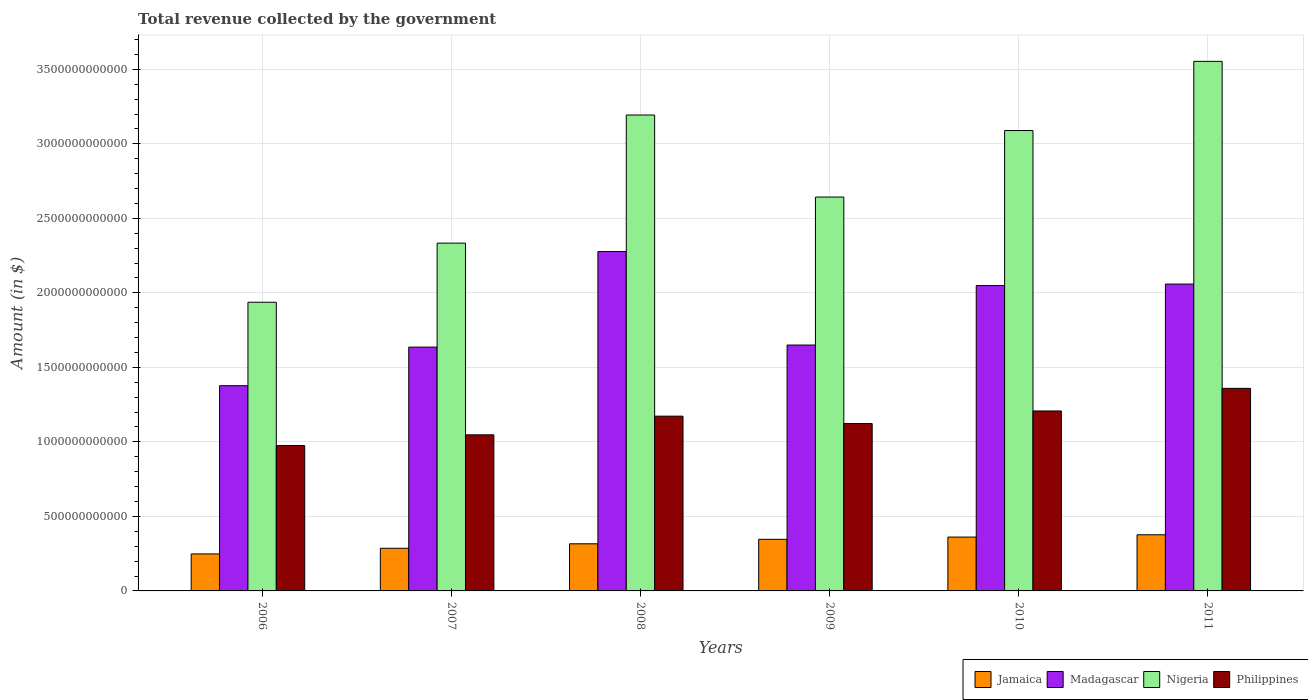How many different coloured bars are there?
Ensure brevity in your answer.  4. How many groups of bars are there?
Your answer should be compact. 6. Are the number of bars per tick equal to the number of legend labels?
Your response must be concise. Yes. Are the number of bars on each tick of the X-axis equal?
Give a very brief answer. Yes. What is the label of the 1st group of bars from the left?
Give a very brief answer. 2006. What is the total revenue collected by the government in Madagascar in 2008?
Provide a succinct answer. 2.28e+12. Across all years, what is the maximum total revenue collected by the government in Nigeria?
Offer a terse response. 3.55e+12. Across all years, what is the minimum total revenue collected by the government in Madagascar?
Ensure brevity in your answer.  1.38e+12. In which year was the total revenue collected by the government in Nigeria maximum?
Ensure brevity in your answer.  2011. What is the total total revenue collected by the government in Madagascar in the graph?
Your response must be concise. 1.10e+13. What is the difference between the total revenue collected by the government in Jamaica in 2006 and that in 2011?
Offer a very short reply. -1.29e+11. What is the difference between the total revenue collected by the government in Madagascar in 2008 and the total revenue collected by the government in Nigeria in 2009?
Your answer should be very brief. -3.66e+11. What is the average total revenue collected by the government in Madagascar per year?
Ensure brevity in your answer.  1.84e+12. In the year 2007, what is the difference between the total revenue collected by the government in Philippines and total revenue collected by the government in Nigeria?
Your answer should be very brief. -1.29e+12. In how many years, is the total revenue collected by the government in Madagascar greater than 300000000000 $?
Ensure brevity in your answer.  6. What is the ratio of the total revenue collected by the government in Madagascar in 2006 to that in 2009?
Keep it short and to the point. 0.83. What is the difference between the highest and the second highest total revenue collected by the government in Nigeria?
Offer a terse response. 3.60e+11. What is the difference between the highest and the lowest total revenue collected by the government in Madagascar?
Offer a very short reply. 9.00e+11. Is the sum of the total revenue collected by the government in Philippines in 2007 and 2008 greater than the maximum total revenue collected by the government in Madagascar across all years?
Give a very brief answer. No. Is it the case that in every year, the sum of the total revenue collected by the government in Nigeria and total revenue collected by the government in Madagascar is greater than the sum of total revenue collected by the government in Philippines and total revenue collected by the government in Jamaica?
Provide a succinct answer. No. What does the 3rd bar from the left in 2009 represents?
Make the answer very short. Nigeria. What does the 3rd bar from the right in 2006 represents?
Keep it short and to the point. Madagascar. Are all the bars in the graph horizontal?
Keep it short and to the point. No. What is the difference between two consecutive major ticks on the Y-axis?
Give a very brief answer. 5.00e+11. What is the title of the graph?
Your answer should be very brief. Total revenue collected by the government. Does "Cyprus" appear as one of the legend labels in the graph?
Offer a terse response. No. What is the label or title of the X-axis?
Offer a very short reply. Years. What is the label or title of the Y-axis?
Your answer should be very brief. Amount (in $). What is the Amount (in $) of Jamaica in 2006?
Your answer should be very brief. 2.48e+11. What is the Amount (in $) in Madagascar in 2006?
Provide a succinct answer. 1.38e+12. What is the Amount (in $) of Nigeria in 2006?
Provide a succinct answer. 1.94e+12. What is the Amount (in $) in Philippines in 2006?
Ensure brevity in your answer.  9.75e+11. What is the Amount (in $) in Jamaica in 2007?
Your response must be concise. 2.86e+11. What is the Amount (in $) of Madagascar in 2007?
Your answer should be very brief. 1.64e+12. What is the Amount (in $) in Nigeria in 2007?
Your response must be concise. 2.33e+12. What is the Amount (in $) in Philippines in 2007?
Ensure brevity in your answer.  1.05e+12. What is the Amount (in $) in Jamaica in 2008?
Ensure brevity in your answer.  3.16e+11. What is the Amount (in $) in Madagascar in 2008?
Provide a succinct answer. 2.28e+12. What is the Amount (in $) in Nigeria in 2008?
Your answer should be compact. 3.19e+12. What is the Amount (in $) of Philippines in 2008?
Ensure brevity in your answer.  1.17e+12. What is the Amount (in $) in Jamaica in 2009?
Your answer should be very brief. 3.46e+11. What is the Amount (in $) of Madagascar in 2009?
Offer a very short reply. 1.65e+12. What is the Amount (in $) in Nigeria in 2009?
Make the answer very short. 2.64e+12. What is the Amount (in $) of Philippines in 2009?
Offer a terse response. 1.12e+12. What is the Amount (in $) in Jamaica in 2010?
Ensure brevity in your answer.  3.61e+11. What is the Amount (in $) of Madagascar in 2010?
Your response must be concise. 2.05e+12. What is the Amount (in $) of Nigeria in 2010?
Your response must be concise. 3.09e+12. What is the Amount (in $) of Philippines in 2010?
Keep it short and to the point. 1.21e+12. What is the Amount (in $) in Jamaica in 2011?
Provide a short and direct response. 3.77e+11. What is the Amount (in $) of Madagascar in 2011?
Your answer should be very brief. 2.06e+12. What is the Amount (in $) of Nigeria in 2011?
Offer a very short reply. 3.55e+12. What is the Amount (in $) in Philippines in 2011?
Provide a succinct answer. 1.36e+12. Across all years, what is the maximum Amount (in $) of Jamaica?
Provide a short and direct response. 3.77e+11. Across all years, what is the maximum Amount (in $) in Madagascar?
Give a very brief answer. 2.28e+12. Across all years, what is the maximum Amount (in $) in Nigeria?
Make the answer very short. 3.55e+12. Across all years, what is the maximum Amount (in $) of Philippines?
Give a very brief answer. 1.36e+12. Across all years, what is the minimum Amount (in $) of Jamaica?
Offer a terse response. 2.48e+11. Across all years, what is the minimum Amount (in $) in Madagascar?
Your response must be concise. 1.38e+12. Across all years, what is the minimum Amount (in $) in Nigeria?
Keep it short and to the point. 1.94e+12. Across all years, what is the minimum Amount (in $) of Philippines?
Give a very brief answer. 9.75e+11. What is the total Amount (in $) in Jamaica in the graph?
Ensure brevity in your answer.  1.93e+12. What is the total Amount (in $) in Madagascar in the graph?
Your answer should be very brief. 1.10e+13. What is the total Amount (in $) in Nigeria in the graph?
Your answer should be compact. 1.67e+13. What is the total Amount (in $) in Philippines in the graph?
Your response must be concise. 6.88e+12. What is the difference between the Amount (in $) of Jamaica in 2006 and that in 2007?
Give a very brief answer. -3.78e+1. What is the difference between the Amount (in $) of Madagascar in 2006 and that in 2007?
Your answer should be very brief. -2.59e+11. What is the difference between the Amount (in $) of Nigeria in 2006 and that in 2007?
Provide a succinct answer. -3.97e+11. What is the difference between the Amount (in $) in Philippines in 2006 and that in 2007?
Offer a very short reply. -7.21e+1. What is the difference between the Amount (in $) of Jamaica in 2006 and that in 2008?
Ensure brevity in your answer.  -6.80e+1. What is the difference between the Amount (in $) in Madagascar in 2006 and that in 2008?
Make the answer very short. -9.00e+11. What is the difference between the Amount (in $) in Nigeria in 2006 and that in 2008?
Offer a very short reply. -1.26e+12. What is the difference between the Amount (in $) in Philippines in 2006 and that in 2008?
Your answer should be compact. -1.97e+11. What is the difference between the Amount (in $) of Jamaica in 2006 and that in 2009?
Keep it short and to the point. -9.79e+1. What is the difference between the Amount (in $) in Madagascar in 2006 and that in 2009?
Your answer should be very brief. -2.73e+11. What is the difference between the Amount (in $) of Nigeria in 2006 and that in 2009?
Provide a short and direct response. -7.06e+11. What is the difference between the Amount (in $) in Philippines in 2006 and that in 2009?
Offer a terse response. -1.48e+11. What is the difference between the Amount (in $) of Jamaica in 2006 and that in 2010?
Ensure brevity in your answer.  -1.13e+11. What is the difference between the Amount (in $) in Madagascar in 2006 and that in 2010?
Keep it short and to the point. -6.72e+11. What is the difference between the Amount (in $) of Nigeria in 2006 and that in 2010?
Ensure brevity in your answer.  -1.15e+12. What is the difference between the Amount (in $) of Philippines in 2006 and that in 2010?
Provide a short and direct response. -2.32e+11. What is the difference between the Amount (in $) of Jamaica in 2006 and that in 2011?
Provide a short and direct response. -1.29e+11. What is the difference between the Amount (in $) of Madagascar in 2006 and that in 2011?
Your response must be concise. -6.82e+11. What is the difference between the Amount (in $) in Nigeria in 2006 and that in 2011?
Your answer should be compact. -1.62e+12. What is the difference between the Amount (in $) in Philippines in 2006 and that in 2011?
Give a very brief answer. -3.84e+11. What is the difference between the Amount (in $) in Jamaica in 2007 and that in 2008?
Ensure brevity in your answer.  -3.02e+1. What is the difference between the Amount (in $) of Madagascar in 2007 and that in 2008?
Offer a very short reply. -6.41e+11. What is the difference between the Amount (in $) of Nigeria in 2007 and that in 2008?
Offer a very short reply. -8.60e+11. What is the difference between the Amount (in $) in Philippines in 2007 and that in 2008?
Your answer should be very brief. -1.25e+11. What is the difference between the Amount (in $) in Jamaica in 2007 and that in 2009?
Offer a terse response. -6.01e+1. What is the difference between the Amount (in $) in Madagascar in 2007 and that in 2009?
Your answer should be compact. -1.38e+1. What is the difference between the Amount (in $) of Nigeria in 2007 and that in 2009?
Provide a succinct answer. -3.09e+11. What is the difference between the Amount (in $) of Philippines in 2007 and that in 2009?
Keep it short and to the point. -7.56e+1. What is the difference between the Amount (in $) in Jamaica in 2007 and that in 2010?
Give a very brief answer. -7.53e+1. What is the difference between the Amount (in $) in Madagascar in 2007 and that in 2010?
Your answer should be compact. -4.13e+11. What is the difference between the Amount (in $) of Nigeria in 2007 and that in 2010?
Keep it short and to the point. -7.56e+11. What is the difference between the Amount (in $) of Philippines in 2007 and that in 2010?
Your answer should be very brief. -1.60e+11. What is the difference between the Amount (in $) of Jamaica in 2007 and that in 2011?
Ensure brevity in your answer.  -9.07e+1. What is the difference between the Amount (in $) in Madagascar in 2007 and that in 2011?
Your answer should be very brief. -4.23e+11. What is the difference between the Amount (in $) of Nigeria in 2007 and that in 2011?
Offer a terse response. -1.22e+12. What is the difference between the Amount (in $) of Philippines in 2007 and that in 2011?
Offer a very short reply. -3.12e+11. What is the difference between the Amount (in $) in Jamaica in 2008 and that in 2009?
Offer a very short reply. -2.99e+1. What is the difference between the Amount (in $) in Madagascar in 2008 and that in 2009?
Provide a succinct answer. 6.27e+11. What is the difference between the Amount (in $) in Nigeria in 2008 and that in 2009?
Offer a very short reply. 5.51e+11. What is the difference between the Amount (in $) in Philippines in 2008 and that in 2009?
Keep it short and to the point. 4.97e+1. What is the difference between the Amount (in $) of Jamaica in 2008 and that in 2010?
Give a very brief answer. -4.51e+1. What is the difference between the Amount (in $) of Madagascar in 2008 and that in 2010?
Offer a very short reply. 2.28e+11. What is the difference between the Amount (in $) of Nigeria in 2008 and that in 2010?
Ensure brevity in your answer.  1.04e+11. What is the difference between the Amount (in $) in Philippines in 2008 and that in 2010?
Your answer should be very brief. -3.49e+1. What is the difference between the Amount (in $) in Jamaica in 2008 and that in 2011?
Your answer should be very brief. -6.06e+1. What is the difference between the Amount (in $) in Madagascar in 2008 and that in 2011?
Make the answer very short. 2.18e+11. What is the difference between the Amount (in $) in Nigeria in 2008 and that in 2011?
Make the answer very short. -3.60e+11. What is the difference between the Amount (in $) of Philippines in 2008 and that in 2011?
Provide a short and direct response. -1.87e+11. What is the difference between the Amount (in $) of Jamaica in 2009 and that in 2010?
Ensure brevity in your answer.  -1.52e+1. What is the difference between the Amount (in $) of Madagascar in 2009 and that in 2010?
Give a very brief answer. -3.99e+11. What is the difference between the Amount (in $) in Nigeria in 2009 and that in 2010?
Give a very brief answer. -4.46e+11. What is the difference between the Amount (in $) of Philippines in 2009 and that in 2010?
Your answer should be very brief. -8.46e+1. What is the difference between the Amount (in $) of Jamaica in 2009 and that in 2011?
Provide a short and direct response. -3.07e+1. What is the difference between the Amount (in $) in Madagascar in 2009 and that in 2011?
Your answer should be very brief. -4.09e+11. What is the difference between the Amount (in $) in Nigeria in 2009 and that in 2011?
Give a very brief answer. -9.11e+11. What is the difference between the Amount (in $) in Philippines in 2009 and that in 2011?
Your answer should be very brief. -2.36e+11. What is the difference between the Amount (in $) in Jamaica in 2010 and that in 2011?
Your answer should be compact. -1.55e+1. What is the difference between the Amount (in $) of Madagascar in 2010 and that in 2011?
Your response must be concise. -9.95e+09. What is the difference between the Amount (in $) of Nigeria in 2010 and that in 2011?
Provide a short and direct response. -4.64e+11. What is the difference between the Amount (in $) in Philippines in 2010 and that in 2011?
Offer a terse response. -1.52e+11. What is the difference between the Amount (in $) of Jamaica in 2006 and the Amount (in $) of Madagascar in 2007?
Ensure brevity in your answer.  -1.39e+12. What is the difference between the Amount (in $) of Jamaica in 2006 and the Amount (in $) of Nigeria in 2007?
Make the answer very short. -2.09e+12. What is the difference between the Amount (in $) of Jamaica in 2006 and the Amount (in $) of Philippines in 2007?
Ensure brevity in your answer.  -7.99e+11. What is the difference between the Amount (in $) of Madagascar in 2006 and the Amount (in $) of Nigeria in 2007?
Provide a short and direct response. -9.57e+11. What is the difference between the Amount (in $) of Madagascar in 2006 and the Amount (in $) of Philippines in 2007?
Make the answer very short. 3.30e+11. What is the difference between the Amount (in $) in Nigeria in 2006 and the Amount (in $) in Philippines in 2007?
Keep it short and to the point. 8.90e+11. What is the difference between the Amount (in $) of Jamaica in 2006 and the Amount (in $) of Madagascar in 2008?
Your answer should be very brief. -2.03e+12. What is the difference between the Amount (in $) in Jamaica in 2006 and the Amount (in $) in Nigeria in 2008?
Offer a very short reply. -2.95e+12. What is the difference between the Amount (in $) of Jamaica in 2006 and the Amount (in $) of Philippines in 2008?
Provide a short and direct response. -9.24e+11. What is the difference between the Amount (in $) in Madagascar in 2006 and the Amount (in $) in Nigeria in 2008?
Offer a terse response. -1.82e+12. What is the difference between the Amount (in $) in Madagascar in 2006 and the Amount (in $) in Philippines in 2008?
Provide a short and direct response. 2.04e+11. What is the difference between the Amount (in $) in Nigeria in 2006 and the Amount (in $) in Philippines in 2008?
Your answer should be compact. 7.64e+11. What is the difference between the Amount (in $) in Jamaica in 2006 and the Amount (in $) in Madagascar in 2009?
Your answer should be very brief. -1.40e+12. What is the difference between the Amount (in $) of Jamaica in 2006 and the Amount (in $) of Nigeria in 2009?
Provide a short and direct response. -2.39e+12. What is the difference between the Amount (in $) of Jamaica in 2006 and the Amount (in $) of Philippines in 2009?
Provide a succinct answer. -8.75e+11. What is the difference between the Amount (in $) of Madagascar in 2006 and the Amount (in $) of Nigeria in 2009?
Provide a short and direct response. -1.27e+12. What is the difference between the Amount (in $) in Madagascar in 2006 and the Amount (in $) in Philippines in 2009?
Offer a terse response. 2.54e+11. What is the difference between the Amount (in $) in Nigeria in 2006 and the Amount (in $) in Philippines in 2009?
Provide a short and direct response. 8.14e+11. What is the difference between the Amount (in $) of Jamaica in 2006 and the Amount (in $) of Madagascar in 2010?
Your response must be concise. -1.80e+12. What is the difference between the Amount (in $) of Jamaica in 2006 and the Amount (in $) of Nigeria in 2010?
Provide a succinct answer. -2.84e+12. What is the difference between the Amount (in $) of Jamaica in 2006 and the Amount (in $) of Philippines in 2010?
Give a very brief answer. -9.59e+11. What is the difference between the Amount (in $) of Madagascar in 2006 and the Amount (in $) of Nigeria in 2010?
Your answer should be compact. -1.71e+12. What is the difference between the Amount (in $) of Madagascar in 2006 and the Amount (in $) of Philippines in 2010?
Provide a short and direct response. 1.70e+11. What is the difference between the Amount (in $) in Nigeria in 2006 and the Amount (in $) in Philippines in 2010?
Ensure brevity in your answer.  7.30e+11. What is the difference between the Amount (in $) of Jamaica in 2006 and the Amount (in $) of Madagascar in 2011?
Your response must be concise. -1.81e+12. What is the difference between the Amount (in $) in Jamaica in 2006 and the Amount (in $) in Nigeria in 2011?
Your answer should be compact. -3.31e+12. What is the difference between the Amount (in $) in Jamaica in 2006 and the Amount (in $) in Philippines in 2011?
Keep it short and to the point. -1.11e+12. What is the difference between the Amount (in $) of Madagascar in 2006 and the Amount (in $) of Nigeria in 2011?
Keep it short and to the point. -2.18e+12. What is the difference between the Amount (in $) in Madagascar in 2006 and the Amount (in $) in Philippines in 2011?
Keep it short and to the point. 1.79e+1. What is the difference between the Amount (in $) in Nigeria in 2006 and the Amount (in $) in Philippines in 2011?
Your answer should be compact. 5.78e+11. What is the difference between the Amount (in $) of Jamaica in 2007 and the Amount (in $) of Madagascar in 2008?
Offer a terse response. -1.99e+12. What is the difference between the Amount (in $) in Jamaica in 2007 and the Amount (in $) in Nigeria in 2008?
Offer a very short reply. -2.91e+12. What is the difference between the Amount (in $) in Jamaica in 2007 and the Amount (in $) in Philippines in 2008?
Provide a short and direct response. -8.87e+11. What is the difference between the Amount (in $) in Madagascar in 2007 and the Amount (in $) in Nigeria in 2008?
Provide a short and direct response. -1.56e+12. What is the difference between the Amount (in $) in Madagascar in 2007 and the Amount (in $) in Philippines in 2008?
Make the answer very short. 4.63e+11. What is the difference between the Amount (in $) in Nigeria in 2007 and the Amount (in $) in Philippines in 2008?
Your answer should be very brief. 1.16e+12. What is the difference between the Amount (in $) of Jamaica in 2007 and the Amount (in $) of Madagascar in 2009?
Keep it short and to the point. -1.36e+12. What is the difference between the Amount (in $) of Jamaica in 2007 and the Amount (in $) of Nigeria in 2009?
Keep it short and to the point. -2.36e+12. What is the difference between the Amount (in $) in Jamaica in 2007 and the Amount (in $) in Philippines in 2009?
Provide a short and direct response. -8.37e+11. What is the difference between the Amount (in $) of Madagascar in 2007 and the Amount (in $) of Nigeria in 2009?
Make the answer very short. -1.01e+12. What is the difference between the Amount (in $) in Madagascar in 2007 and the Amount (in $) in Philippines in 2009?
Offer a terse response. 5.13e+11. What is the difference between the Amount (in $) of Nigeria in 2007 and the Amount (in $) of Philippines in 2009?
Offer a very short reply. 1.21e+12. What is the difference between the Amount (in $) of Jamaica in 2007 and the Amount (in $) of Madagascar in 2010?
Provide a succinct answer. -1.76e+12. What is the difference between the Amount (in $) in Jamaica in 2007 and the Amount (in $) in Nigeria in 2010?
Keep it short and to the point. -2.80e+12. What is the difference between the Amount (in $) of Jamaica in 2007 and the Amount (in $) of Philippines in 2010?
Keep it short and to the point. -9.21e+11. What is the difference between the Amount (in $) of Madagascar in 2007 and the Amount (in $) of Nigeria in 2010?
Your answer should be very brief. -1.45e+12. What is the difference between the Amount (in $) of Madagascar in 2007 and the Amount (in $) of Philippines in 2010?
Ensure brevity in your answer.  4.29e+11. What is the difference between the Amount (in $) of Nigeria in 2007 and the Amount (in $) of Philippines in 2010?
Your answer should be compact. 1.13e+12. What is the difference between the Amount (in $) in Jamaica in 2007 and the Amount (in $) in Madagascar in 2011?
Make the answer very short. -1.77e+12. What is the difference between the Amount (in $) in Jamaica in 2007 and the Amount (in $) in Nigeria in 2011?
Provide a succinct answer. -3.27e+12. What is the difference between the Amount (in $) of Jamaica in 2007 and the Amount (in $) of Philippines in 2011?
Give a very brief answer. -1.07e+12. What is the difference between the Amount (in $) of Madagascar in 2007 and the Amount (in $) of Nigeria in 2011?
Your answer should be compact. -1.92e+12. What is the difference between the Amount (in $) in Madagascar in 2007 and the Amount (in $) in Philippines in 2011?
Keep it short and to the point. 2.77e+11. What is the difference between the Amount (in $) in Nigeria in 2007 and the Amount (in $) in Philippines in 2011?
Provide a short and direct response. 9.75e+11. What is the difference between the Amount (in $) of Jamaica in 2008 and the Amount (in $) of Madagascar in 2009?
Offer a terse response. -1.33e+12. What is the difference between the Amount (in $) in Jamaica in 2008 and the Amount (in $) in Nigeria in 2009?
Ensure brevity in your answer.  -2.33e+12. What is the difference between the Amount (in $) in Jamaica in 2008 and the Amount (in $) in Philippines in 2009?
Your response must be concise. -8.07e+11. What is the difference between the Amount (in $) in Madagascar in 2008 and the Amount (in $) in Nigeria in 2009?
Ensure brevity in your answer.  -3.66e+11. What is the difference between the Amount (in $) of Madagascar in 2008 and the Amount (in $) of Philippines in 2009?
Offer a very short reply. 1.15e+12. What is the difference between the Amount (in $) in Nigeria in 2008 and the Amount (in $) in Philippines in 2009?
Provide a short and direct response. 2.07e+12. What is the difference between the Amount (in $) of Jamaica in 2008 and the Amount (in $) of Madagascar in 2010?
Offer a very short reply. -1.73e+12. What is the difference between the Amount (in $) of Jamaica in 2008 and the Amount (in $) of Nigeria in 2010?
Ensure brevity in your answer.  -2.77e+12. What is the difference between the Amount (in $) of Jamaica in 2008 and the Amount (in $) of Philippines in 2010?
Your response must be concise. -8.91e+11. What is the difference between the Amount (in $) of Madagascar in 2008 and the Amount (in $) of Nigeria in 2010?
Ensure brevity in your answer.  -8.12e+11. What is the difference between the Amount (in $) in Madagascar in 2008 and the Amount (in $) in Philippines in 2010?
Offer a terse response. 1.07e+12. What is the difference between the Amount (in $) in Nigeria in 2008 and the Amount (in $) in Philippines in 2010?
Your answer should be very brief. 1.99e+12. What is the difference between the Amount (in $) in Jamaica in 2008 and the Amount (in $) in Madagascar in 2011?
Offer a terse response. -1.74e+12. What is the difference between the Amount (in $) of Jamaica in 2008 and the Amount (in $) of Nigeria in 2011?
Your answer should be very brief. -3.24e+12. What is the difference between the Amount (in $) of Jamaica in 2008 and the Amount (in $) of Philippines in 2011?
Provide a short and direct response. -1.04e+12. What is the difference between the Amount (in $) in Madagascar in 2008 and the Amount (in $) in Nigeria in 2011?
Make the answer very short. -1.28e+12. What is the difference between the Amount (in $) of Madagascar in 2008 and the Amount (in $) of Philippines in 2011?
Keep it short and to the point. 9.18e+11. What is the difference between the Amount (in $) of Nigeria in 2008 and the Amount (in $) of Philippines in 2011?
Your answer should be very brief. 1.83e+12. What is the difference between the Amount (in $) of Jamaica in 2009 and the Amount (in $) of Madagascar in 2010?
Offer a terse response. -1.70e+12. What is the difference between the Amount (in $) in Jamaica in 2009 and the Amount (in $) in Nigeria in 2010?
Provide a short and direct response. -2.74e+12. What is the difference between the Amount (in $) in Jamaica in 2009 and the Amount (in $) in Philippines in 2010?
Give a very brief answer. -8.61e+11. What is the difference between the Amount (in $) in Madagascar in 2009 and the Amount (in $) in Nigeria in 2010?
Your answer should be very brief. -1.44e+12. What is the difference between the Amount (in $) of Madagascar in 2009 and the Amount (in $) of Philippines in 2010?
Your answer should be compact. 4.42e+11. What is the difference between the Amount (in $) of Nigeria in 2009 and the Amount (in $) of Philippines in 2010?
Your answer should be compact. 1.44e+12. What is the difference between the Amount (in $) in Jamaica in 2009 and the Amount (in $) in Madagascar in 2011?
Offer a terse response. -1.71e+12. What is the difference between the Amount (in $) in Jamaica in 2009 and the Amount (in $) in Nigeria in 2011?
Keep it short and to the point. -3.21e+12. What is the difference between the Amount (in $) in Jamaica in 2009 and the Amount (in $) in Philippines in 2011?
Offer a terse response. -1.01e+12. What is the difference between the Amount (in $) of Madagascar in 2009 and the Amount (in $) of Nigeria in 2011?
Offer a terse response. -1.90e+12. What is the difference between the Amount (in $) in Madagascar in 2009 and the Amount (in $) in Philippines in 2011?
Give a very brief answer. 2.91e+11. What is the difference between the Amount (in $) in Nigeria in 2009 and the Amount (in $) in Philippines in 2011?
Your answer should be compact. 1.28e+12. What is the difference between the Amount (in $) in Jamaica in 2010 and the Amount (in $) in Madagascar in 2011?
Keep it short and to the point. -1.70e+12. What is the difference between the Amount (in $) in Jamaica in 2010 and the Amount (in $) in Nigeria in 2011?
Provide a succinct answer. -3.19e+12. What is the difference between the Amount (in $) of Jamaica in 2010 and the Amount (in $) of Philippines in 2011?
Your answer should be very brief. -9.98e+11. What is the difference between the Amount (in $) of Madagascar in 2010 and the Amount (in $) of Nigeria in 2011?
Ensure brevity in your answer.  -1.50e+12. What is the difference between the Amount (in $) in Madagascar in 2010 and the Amount (in $) in Philippines in 2011?
Ensure brevity in your answer.  6.90e+11. What is the difference between the Amount (in $) in Nigeria in 2010 and the Amount (in $) in Philippines in 2011?
Your answer should be compact. 1.73e+12. What is the average Amount (in $) of Jamaica per year?
Provide a short and direct response. 3.22e+11. What is the average Amount (in $) of Madagascar per year?
Provide a succinct answer. 1.84e+12. What is the average Amount (in $) in Nigeria per year?
Offer a terse response. 2.79e+12. What is the average Amount (in $) in Philippines per year?
Your answer should be very brief. 1.15e+12. In the year 2006, what is the difference between the Amount (in $) of Jamaica and Amount (in $) of Madagascar?
Your answer should be compact. -1.13e+12. In the year 2006, what is the difference between the Amount (in $) of Jamaica and Amount (in $) of Nigeria?
Offer a very short reply. -1.69e+12. In the year 2006, what is the difference between the Amount (in $) in Jamaica and Amount (in $) in Philippines?
Keep it short and to the point. -7.27e+11. In the year 2006, what is the difference between the Amount (in $) of Madagascar and Amount (in $) of Nigeria?
Provide a succinct answer. -5.60e+11. In the year 2006, what is the difference between the Amount (in $) in Madagascar and Amount (in $) in Philippines?
Offer a terse response. 4.02e+11. In the year 2006, what is the difference between the Amount (in $) of Nigeria and Amount (in $) of Philippines?
Your answer should be very brief. 9.62e+11. In the year 2007, what is the difference between the Amount (in $) in Jamaica and Amount (in $) in Madagascar?
Provide a short and direct response. -1.35e+12. In the year 2007, what is the difference between the Amount (in $) of Jamaica and Amount (in $) of Nigeria?
Your response must be concise. -2.05e+12. In the year 2007, what is the difference between the Amount (in $) in Jamaica and Amount (in $) in Philippines?
Offer a very short reply. -7.61e+11. In the year 2007, what is the difference between the Amount (in $) of Madagascar and Amount (in $) of Nigeria?
Provide a short and direct response. -6.98e+11. In the year 2007, what is the difference between the Amount (in $) in Madagascar and Amount (in $) in Philippines?
Your answer should be very brief. 5.89e+11. In the year 2007, what is the difference between the Amount (in $) of Nigeria and Amount (in $) of Philippines?
Your response must be concise. 1.29e+12. In the year 2008, what is the difference between the Amount (in $) of Jamaica and Amount (in $) of Madagascar?
Offer a very short reply. -1.96e+12. In the year 2008, what is the difference between the Amount (in $) in Jamaica and Amount (in $) in Nigeria?
Provide a succinct answer. -2.88e+12. In the year 2008, what is the difference between the Amount (in $) in Jamaica and Amount (in $) in Philippines?
Your response must be concise. -8.56e+11. In the year 2008, what is the difference between the Amount (in $) of Madagascar and Amount (in $) of Nigeria?
Offer a terse response. -9.16e+11. In the year 2008, what is the difference between the Amount (in $) in Madagascar and Amount (in $) in Philippines?
Your answer should be compact. 1.10e+12. In the year 2008, what is the difference between the Amount (in $) of Nigeria and Amount (in $) of Philippines?
Give a very brief answer. 2.02e+12. In the year 2009, what is the difference between the Amount (in $) in Jamaica and Amount (in $) in Madagascar?
Give a very brief answer. -1.30e+12. In the year 2009, what is the difference between the Amount (in $) in Jamaica and Amount (in $) in Nigeria?
Provide a succinct answer. -2.30e+12. In the year 2009, what is the difference between the Amount (in $) of Jamaica and Amount (in $) of Philippines?
Keep it short and to the point. -7.77e+11. In the year 2009, what is the difference between the Amount (in $) in Madagascar and Amount (in $) in Nigeria?
Your response must be concise. -9.93e+11. In the year 2009, what is the difference between the Amount (in $) in Madagascar and Amount (in $) in Philippines?
Provide a succinct answer. 5.27e+11. In the year 2009, what is the difference between the Amount (in $) in Nigeria and Amount (in $) in Philippines?
Your answer should be very brief. 1.52e+12. In the year 2010, what is the difference between the Amount (in $) in Jamaica and Amount (in $) in Madagascar?
Provide a succinct answer. -1.69e+12. In the year 2010, what is the difference between the Amount (in $) of Jamaica and Amount (in $) of Nigeria?
Make the answer very short. -2.73e+12. In the year 2010, what is the difference between the Amount (in $) in Jamaica and Amount (in $) in Philippines?
Your answer should be very brief. -8.46e+11. In the year 2010, what is the difference between the Amount (in $) in Madagascar and Amount (in $) in Nigeria?
Make the answer very short. -1.04e+12. In the year 2010, what is the difference between the Amount (in $) of Madagascar and Amount (in $) of Philippines?
Ensure brevity in your answer.  8.42e+11. In the year 2010, what is the difference between the Amount (in $) of Nigeria and Amount (in $) of Philippines?
Keep it short and to the point. 1.88e+12. In the year 2011, what is the difference between the Amount (in $) in Jamaica and Amount (in $) in Madagascar?
Provide a short and direct response. -1.68e+12. In the year 2011, what is the difference between the Amount (in $) of Jamaica and Amount (in $) of Nigeria?
Give a very brief answer. -3.18e+12. In the year 2011, what is the difference between the Amount (in $) of Jamaica and Amount (in $) of Philippines?
Make the answer very short. -9.82e+11. In the year 2011, what is the difference between the Amount (in $) in Madagascar and Amount (in $) in Nigeria?
Offer a terse response. -1.49e+12. In the year 2011, what is the difference between the Amount (in $) in Madagascar and Amount (in $) in Philippines?
Make the answer very short. 7.00e+11. In the year 2011, what is the difference between the Amount (in $) in Nigeria and Amount (in $) in Philippines?
Your response must be concise. 2.19e+12. What is the ratio of the Amount (in $) of Jamaica in 2006 to that in 2007?
Offer a very short reply. 0.87. What is the ratio of the Amount (in $) of Madagascar in 2006 to that in 2007?
Your response must be concise. 0.84. What is the ratio of the Amount (in $) in Nigeria in 2006 to that in 2007?
Offer a very short reply. 0.83. What is the ratio of the Amount (in $) of Philippines in 2006 to that in 2007?
Your answer should be very brief. 0.93. What is the ratio of the Amount (in $) in Jamaica in 2006 to that in 2008?
Give a very brief answer. 0.78. What is the ratio of the Amount (in $) of Madagascar in 2006 to that in 2008?
Make the answer very short. 0.6. What is the ratio of the Amount (in $) of Nigeria in 2006 to that in 2008?
Your answer should be compact. 0.61. What is the ratio of the Amount (in $) of Philippines in 2006 to that in 2008?
Offer a very short reply. 0.83. What is the ratio of the Amount (in $) of Jamaica in 2006 to that in 2009?
Keep it short and to the point. 0.72. What is the ratio of the Amount (in $) in Madagascar in 2006 to that in 2009?
Give a very brief answer. 0.83. What is the ratio of the Amount (in $) in Nigeria in 2006 to that in 2009?
Ensure brevity in your answer.  0.73. What is the ratio of the Amount (in $) in Philippines in 2006 to that in 2009?
Make the answer very short. 0.87. What is the ratio of the Amount (in $) of Jamaica in 2006 to that in 2010?
Keep it short and to the point. 0.69. What is the ratio of the Amount (in $) of Madagascar in 2006 to that in 2010?
Offer a very short reply. 0.67. What is the ratio of the Amount (in $) of Nigeria in 2006 to that in 2010?
Give a very brief answer. 0.63. What is the ratio of the Amount (in $) of Philippines in 2006 to that in 2010?
Your answer should be compact. 0.81. What is the ratio of the Amount (in $) of Jamaica in 2006 to that in 2011?
Provide a short and direct response. 0.66. What is the ratio of the Amount (in $) of Madagascar in 2006 to that in 2011?
Provide a short and direct response. 0.67. What is the ratio of the Amount (in $) in Nigeria in 2006 to that in 2011?
Ensure brevity in your answer.  0.55. What is the ratio of the Amount (in $) in Philippines in 2006 to that in 2011?
Give a very brief answer. 0.72. What is the ratio of the Amount (in $) of Jamaica in 2007 to that in 2008?
Make the answer very short. 0.9. What is the ratio of the Amount (in $) in Madagascar in 2007 to that in 2008?
Keep it short and to the point. 0.72. What is the ratio of the Amount (in $) in Nigeria in 2007 to that in 2008?
Offer a very short reply. 0.73. What is the ratio of the Amount (in $) in Philippines in 2007 to that in 2008?
Your answer should be compact. 0.89. What is the ratio of the Amount (in $) of Jamaica in 2007 to that in 2009?
Offer a very short reply. 0.83. What is the ratio of the Amount (in $) in Madagascar in 2007 to that in 2009?
Offer a very short reply. 0.99. What is the ratio of the Amount (in $) in Nigeria in 2007 to that in 2009?
Make the answer very short. 0.88. What is the ratio of the Amount (in $) in Philippines in 2007 to that in 2009?
Your response must be concise. 0.93. What is the ratio of the Amount (in $) of Jamaica in 2007 to that in 2010?
Your response must be concise. 0.79. What is the ratio of the Amount (in $) of Madagascar in 2007 to that in 2010?
Your answer should be very brief. 0.8. What is the ratio of the Amount (in $) of Nigeria in 2007 to that in 2010?
Keep it short and to the point. 0.76. What is the ratio of the Amount (in $) of Philippines in 2007 to that in 2010?
Offer a very short reply. 0.87. What is the ratio of the Amount (in $) of Jamaica in 2007 to that in 2011?
Offer a terse response. 0.76. What is the ratio of the Amount (in $) in Madagascar in 2007 to that in 2011?
Make the answer very short. 0.79. What is the ratio of the Amount (in $) of Nigeria in 2007 to that in 2011?
Your answer should be very brief. 0.66. What is the ratio of the Amount (in $) of Philippines in 2007 to that in 2011?
Give a very brief answer. 0.77. What is the ratio of the Amount (in $) in Jamaica in 2008 to that in 2009?
Provide a short and direct response. 0.91. What is the ratio of the Amount (in $) of Madagascar in 2008 to that in 2009?
Your answer should be compact. 1.38. What is the ratio of the Amount (in $) in Nigeria in 2008 to that in 2009?
Offer a very short reply. 1.21. What is the ratio of the Amount (in $) of Philippines in 2008 to that in 2009?
Ensure brevity in your answer.  1.04. What is the ratio of the Amount (in $) of Jamaica in 2008 to that in 2010?
Provide a short and direct response. 0.88. What is the ratio of the Amount (in $) in Madagascar in 2008 to that in 2010?
Make the answer very short. 1.11. What is the ratio of the Amount (in $) in Nigeria in 2008 to that in 2010?
Your answer should be compact. 1.03. What is the ratio of the Amount (in $) of Philippines in 2008 to that in 2010?
Your answer should be very brief. 0.97. What is the ratio of the Amount (in $) in Jamaica in 2008 to that in 2011?
Provide a succinct answer. 0.84. What is the ratio of the Amount (in $) of Madagascar in 2008 to that in 2011?
Offer a terse response. 1.11. What is the ratio of the Amount (in $) of Nigeria in 2008 to that in 2011?
Keep it short and to the point. 0.9. What is the ratio of the Amount (in $) in Philippines in 2008 to that in 2011?
Your response must be concise. 0.86. What is the ratio of the Amount (in $) in Jamaica in 2009 to that in 2010?
Provide a short and direct response. 0.96. What is the ratio of the Amount (in $) in Madagascar in 2009 to that in 2010?
Your answer should be very brief. 0.81. What is the ratio of the Amount (in $) of Nigeria in 2009 to that in 2010?
Provide a short and direct response. 0.86. What is the ratio of the Amount (in $) in Philippines in 2009 to that in 2010?
Provide a short and direct response. 0.93. What is the ratio of the Amount (in $) in Jamaica in 2009 to that in 2011?
Provide a succinct answer. 0.92. What is the ratio of the Amount (in $) of Madagascar in 2009 to that in 2011?
Ensure brevity in your answer.  0.8. What is the ratio of the Amount (in $) of Nigeria in 2009 to that in 2011?
Offer a terse response. 0.74. What is the ratio of the Amount (in $) in Philippines in 2009 to that in 2011?
Ensure brevity in your answer.  0.83. What is the ratio of the Amount (in $) in Nigeria in 2010 to that in 2011?
Provide a short and direct response. 0.87. What is the ratio of the Amount (in $) in Philippines in 2010 to that in 2011?
Provide a succinct answer. 0.89. What is the difference between the highest and the second highest Amount (in $) of Jamaica?
Give a very brief answer. 1.55e+1. What is the difference between the highest and the second highest Amount (in $) in Madagascar?
Keep it short and to the point. 2.18e+11. What is the difference between the highest and the second highest Amount (in $) of Nigeria?
Your response must be concise. 3.60e+11. What is the difference between the highest and the second highest Amount (in $) of Philippines?
Make the answer very short. 1.52e+11. What is the difference between the highest and the lowest Amount (in $) of Jamaica?
Your response must be concise. 1.29e+11. What is the difference between the highest and the lowest Amount (in $) of Madagascar?
Offer a very short reply. 9.00e+11. What is the difference between the highest and the lowest Amount (in $) in Nigeria?
Provide a succinct answer. 1.62e+12. What is the difference between the highest and the lowest Amount (in $) in Philippines?
Your response must be concise. 3.84e+11. 